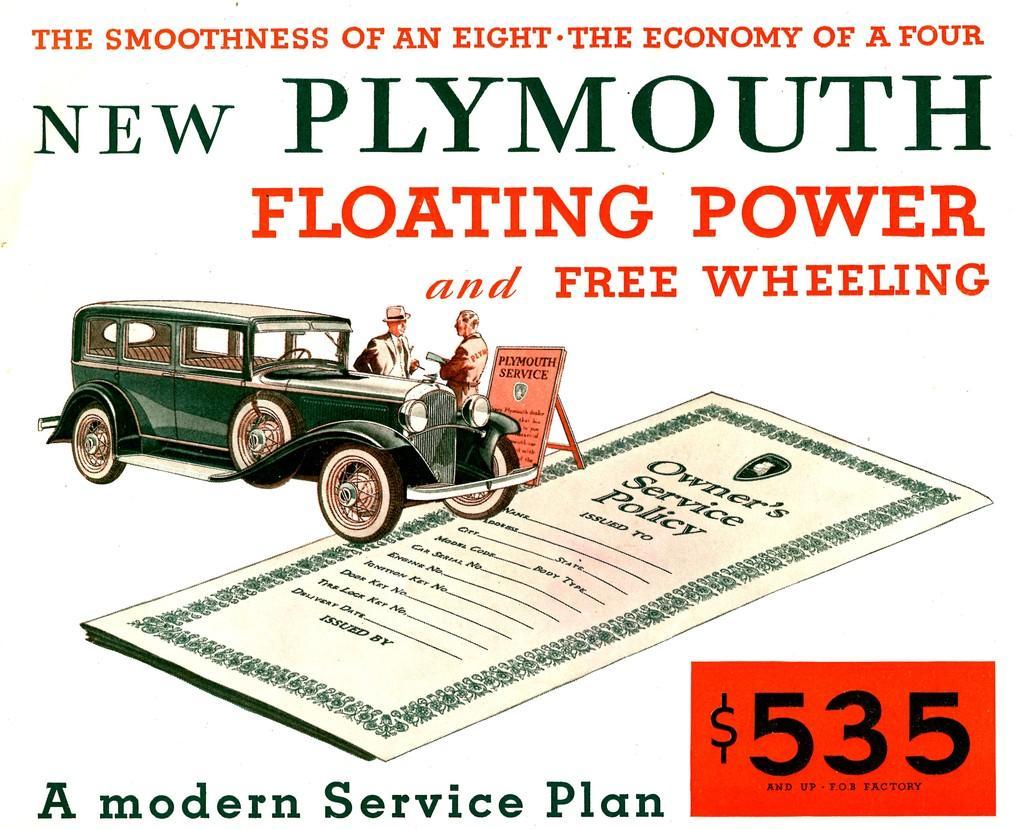Describe this image in one or two sentences. In this image there is a poster with text and a picture of a car and two people. 